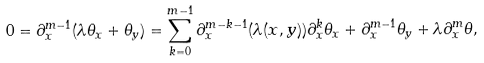<formula> <loc_0><loc_0><loc_500><loc_500>0 = \partial _ { x } ^ { m - 1 } ( \lambda \theta _ { x } + \theta _ { y } ) = \sum _ { k = 0 } ^ { m - 1 } \partial _ { x } ^ { m - k - 1 } ( \lambda ( x , y ) ) \partial _ { x } ^ { k } \theta _ { x } + \partial _ { x } ^ { m - 1 } \theta _ { y } + \lambda \partial _ { x } ^ { m } \theta ,</formula> 